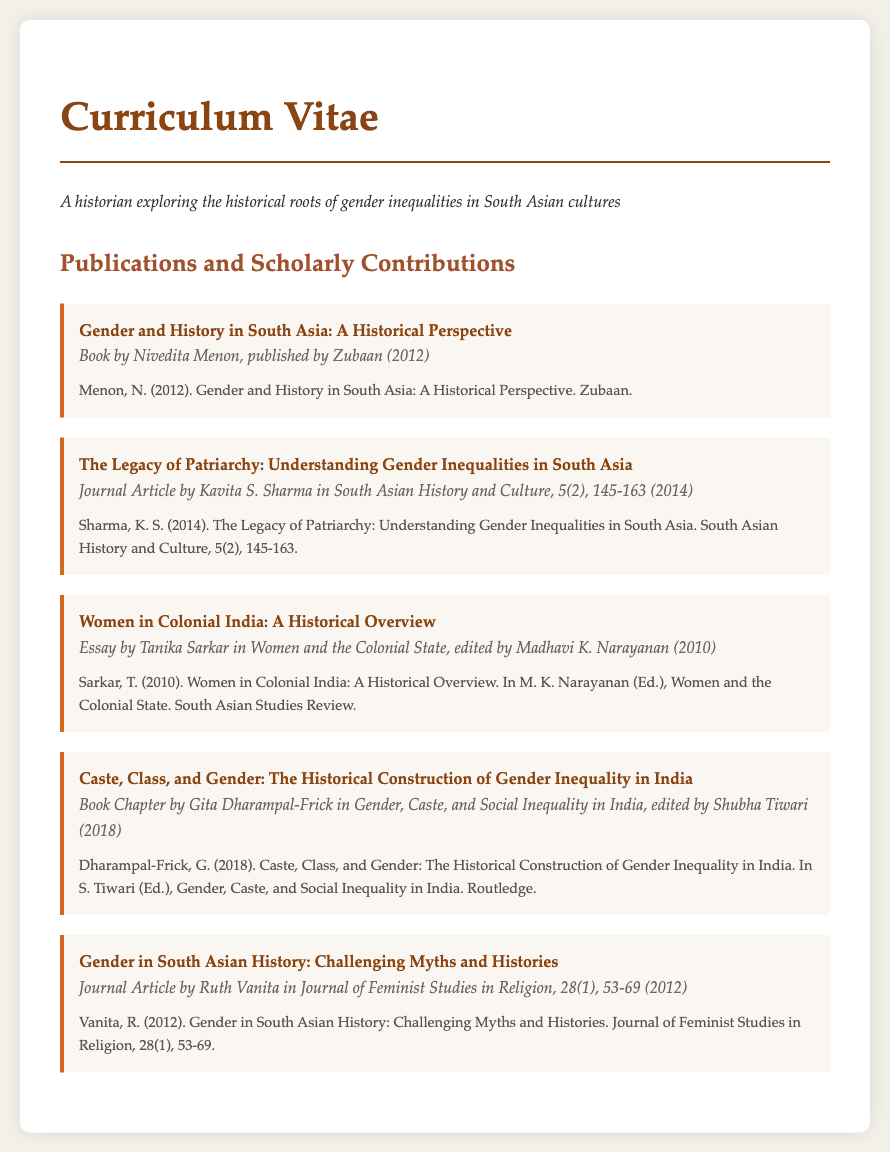what is the title of the first publication? The title of the first publication listed is "Gender and History in South Asia: A Historical Perspective."
Answer: Gender and History in South Asia: A Historical Perspective who is the author of the article published in 2014? The author of the article published in 2014 is Kavita S. Sharma.
Answer: Kavita S. Sharma what type of work is "Women in Colonial India: A Historical Overview"? "Women in Colonial India: A Historical Overview" is categorized as an essay.
Answer: essay in which journal was "Gender in South Asian History: Challenging Myths and Histories" published? "Gender in South Asian History: Challenging Myths and Histories" was published in the Journal of Feminist Studies in Religion.
Answer: Journal of Feminist Studies in Religion what year was "Caste, Class, and Gender" published? "Caste, Class, and Gender" was published in 2018.
Answer: 2018 which publication is edited by Madhavi K. Narayanan? The publication edited by Madhavi K. Narayanan is titled "Women and the Colonial State."
Answer: Women and the Colonial State how many publications are listed in total? The total number of publications listed in the document is five.
Answer: five 